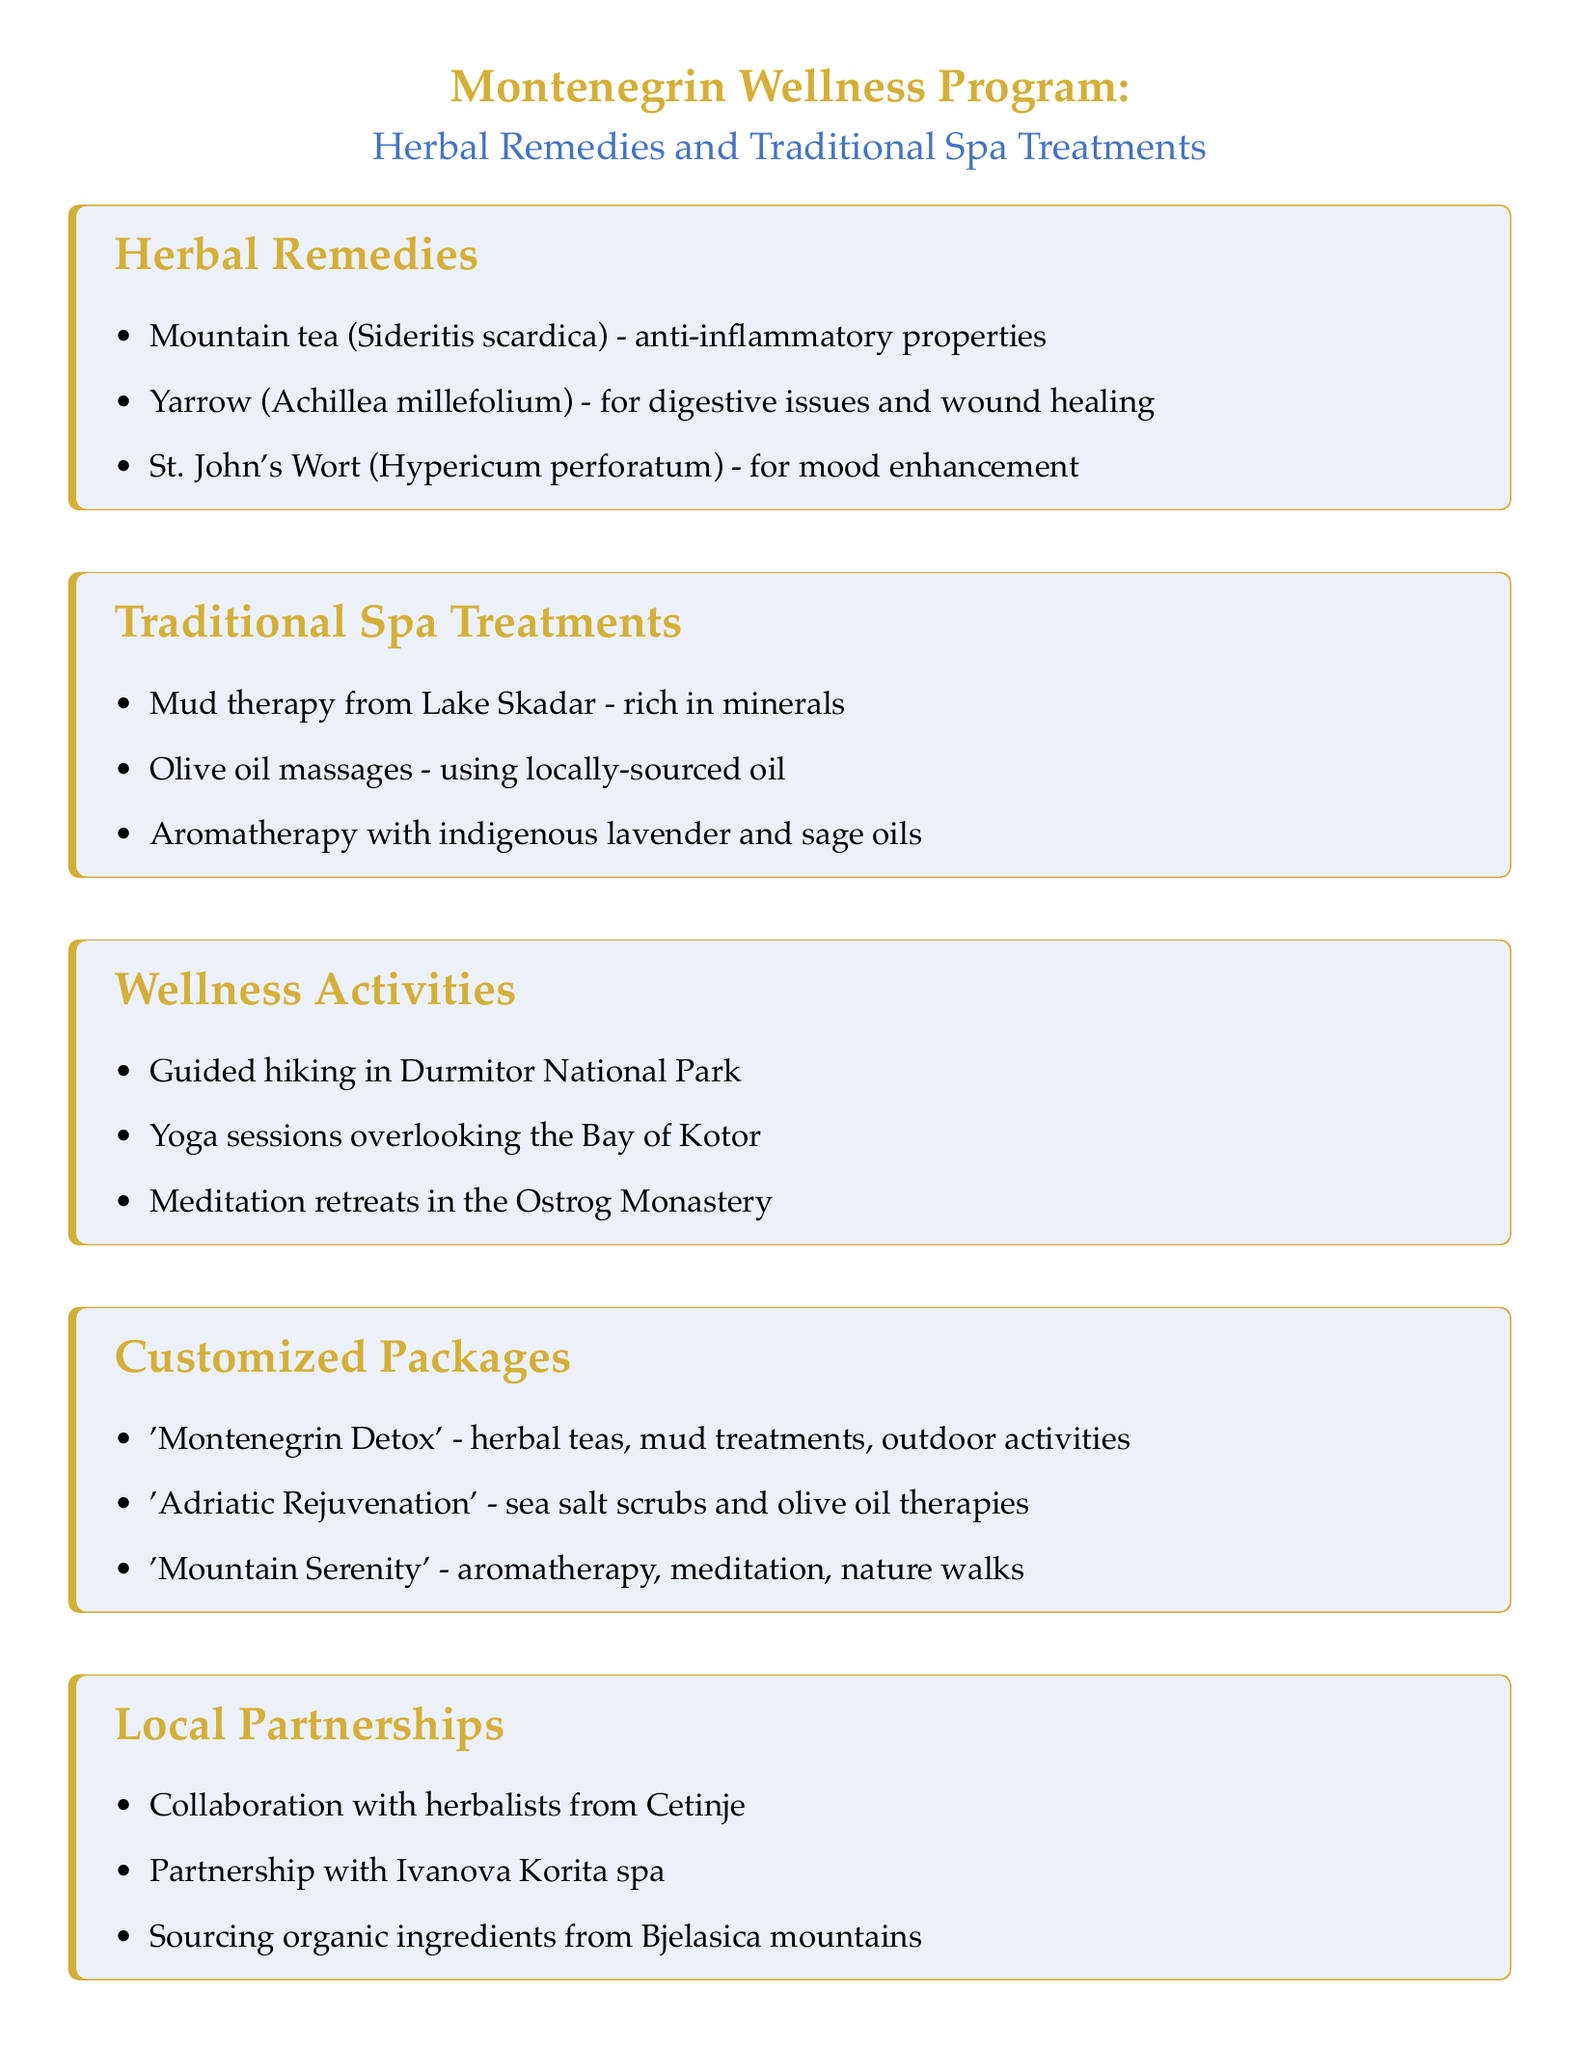What is the first herbal remedy listed? The first herbal remedy mentioned is mountain tea.
Answer: Mountain tea Which spa treatment uses minerals from a lake? The spa treatment that uses minerals from a lake is mud therapy.
Answer: Mud therapy from Lake Skadar How many wellness activities are mentioned? The document lists three wellness activities.
Answer: 3 What is included in the 'Montenegrin Detox' package? The 'Montenegrin Detox' package includes herbal teas, mud treatments, and outdoor activities.
Answer: herbal teas, mud treatments, outdoor activities Where do the organic ingredients come from? Organic ingredients are sourced from small-scale farmers in the Bjelasica mountains.
Answer: Bjelasica mountains What type of partnership is formed with herbalists? The document mentions a collaboration with herbalists from Cetinje.
Answer: Collaboration with herbalists from Cetinje What is one of the wellness activities offered? One of the wellness activities offered is yoga sessions overlooking the Bay of Kotor.
Answer: Yoga sessions overlooking the Bay of Kotor 